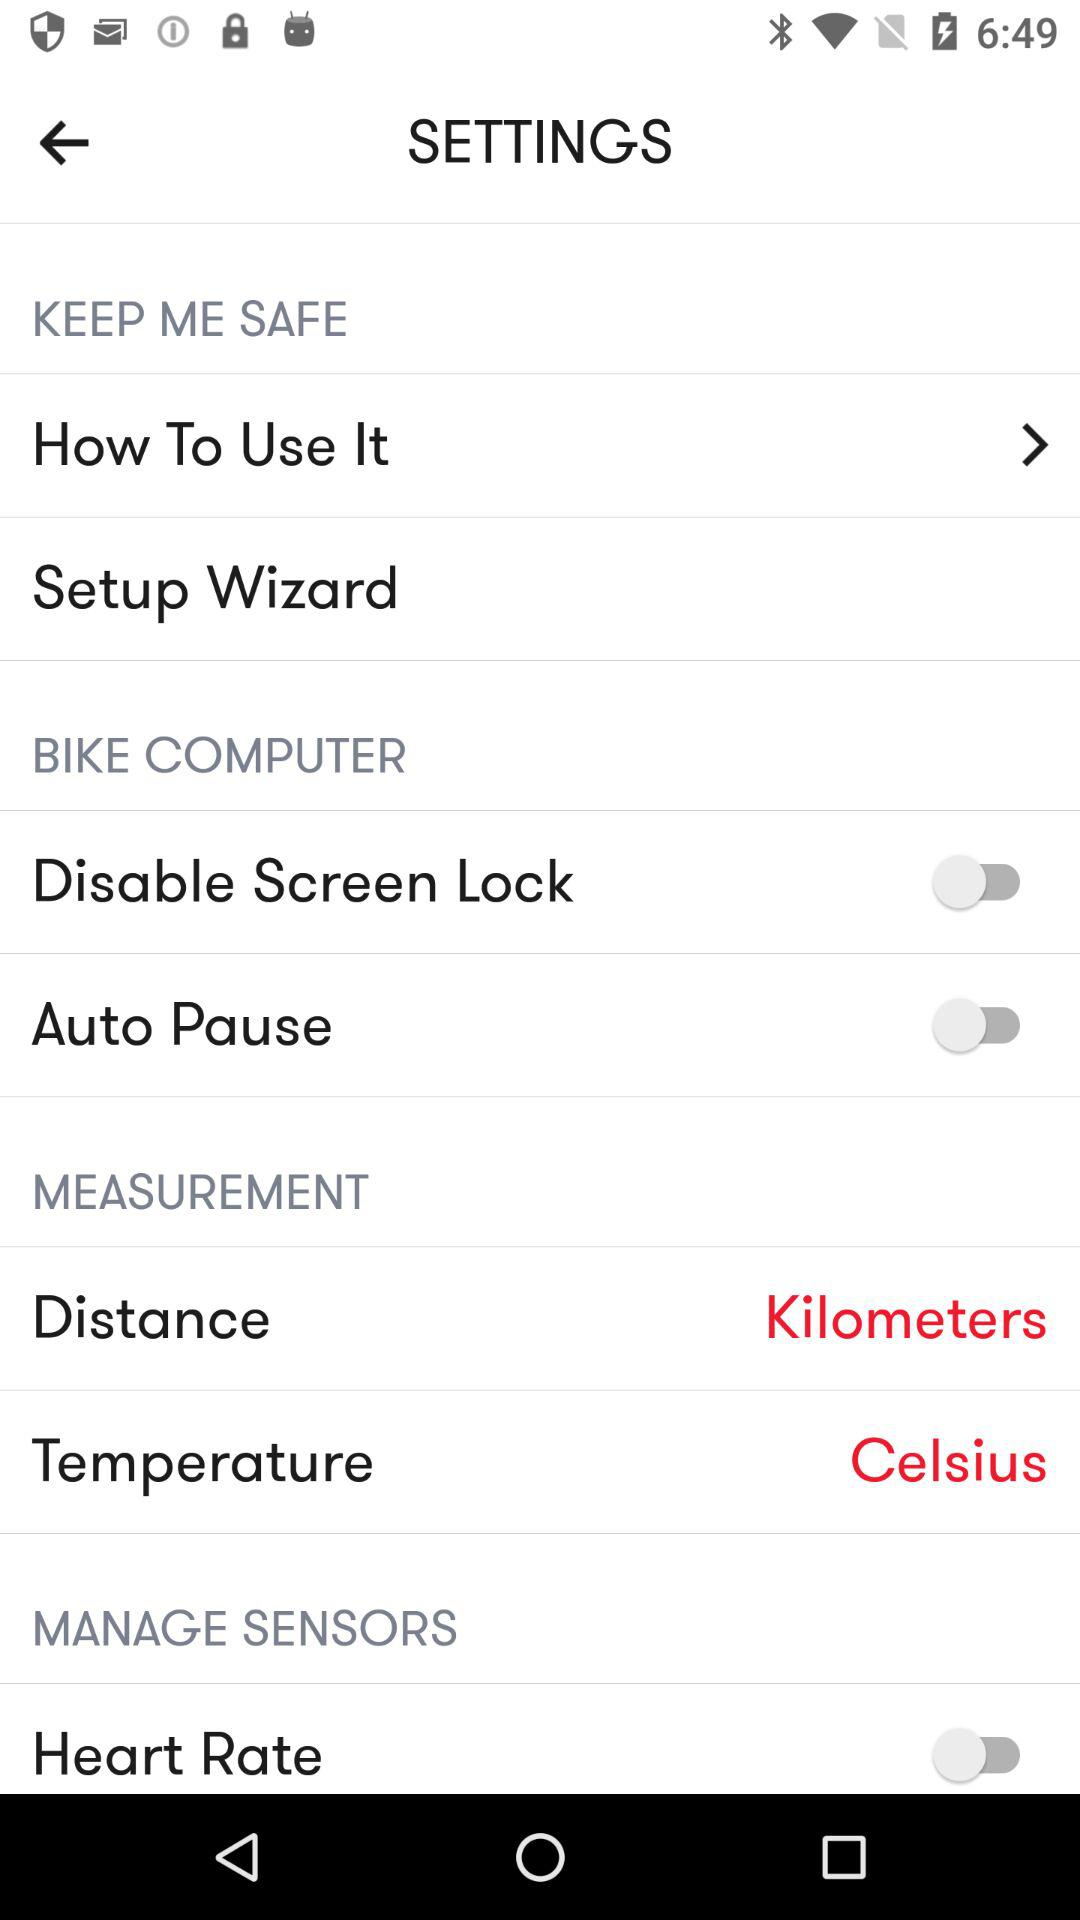Temperature is measured in what unit? The temperature is measured in "Celsius". 